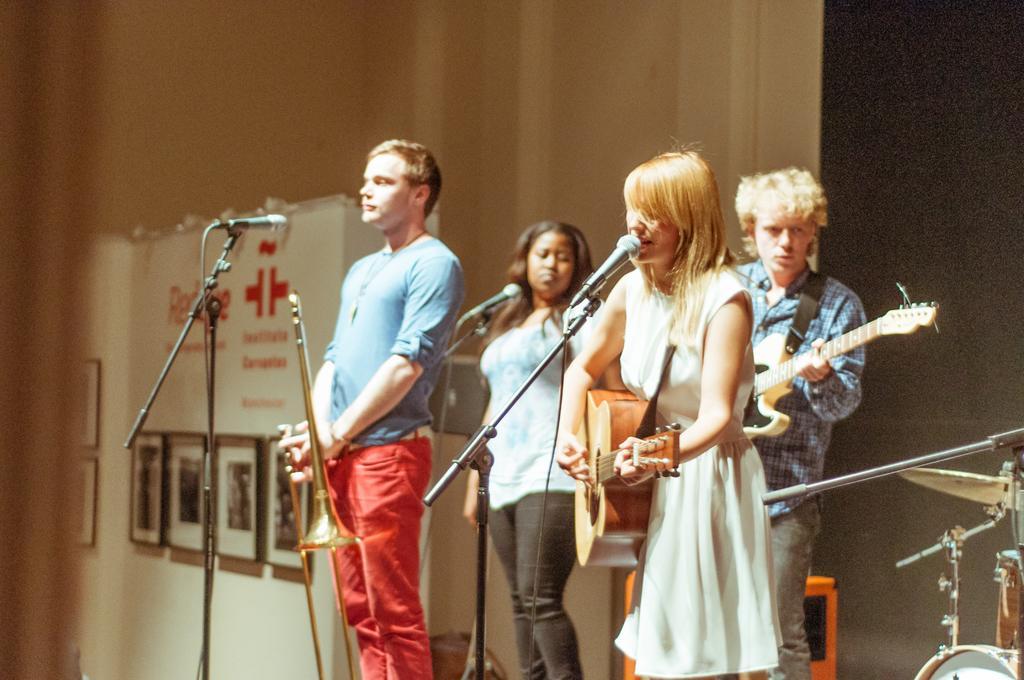How would you summarize this image in a sentence or two? In this picture there are four people standing and this woman is singing she is also playing a guitar and in the backdrop design other person holding the guitar that two people Standing and watching one of them is holding a trumpet 